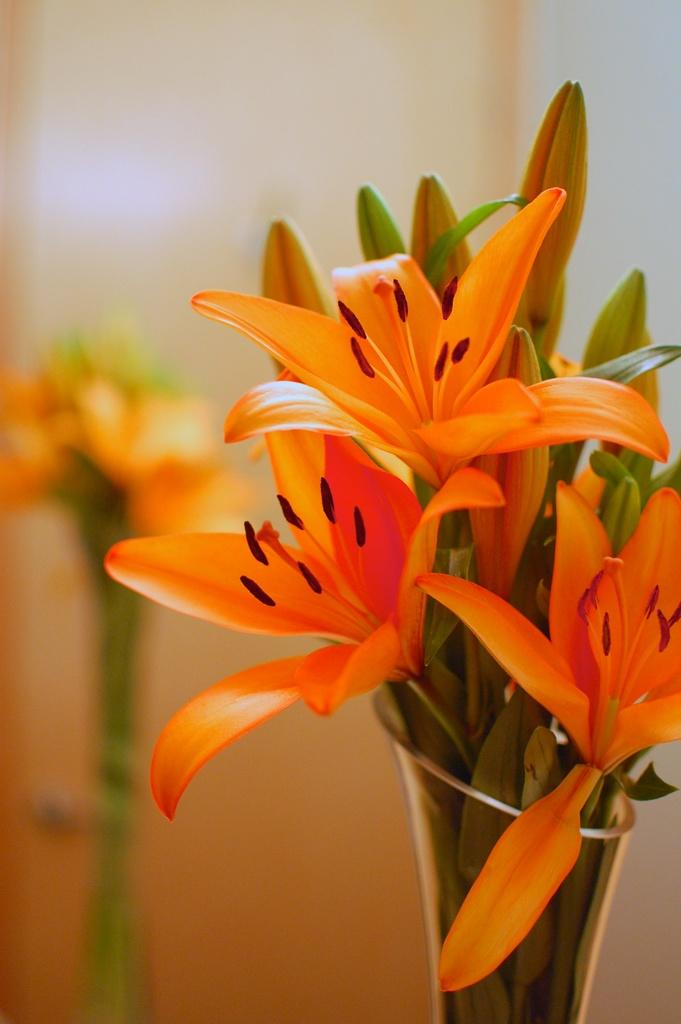What type of objects can be seen in the image? There are flowers in the image. How are the flowers arranged or displayed? The flowers are in a vase. Can you describe the background of the image? The background of the image is blurred. What type of respect can be seen in the image? There is no indication of respect in the image; it features flowers in a vase with a blurred background. 